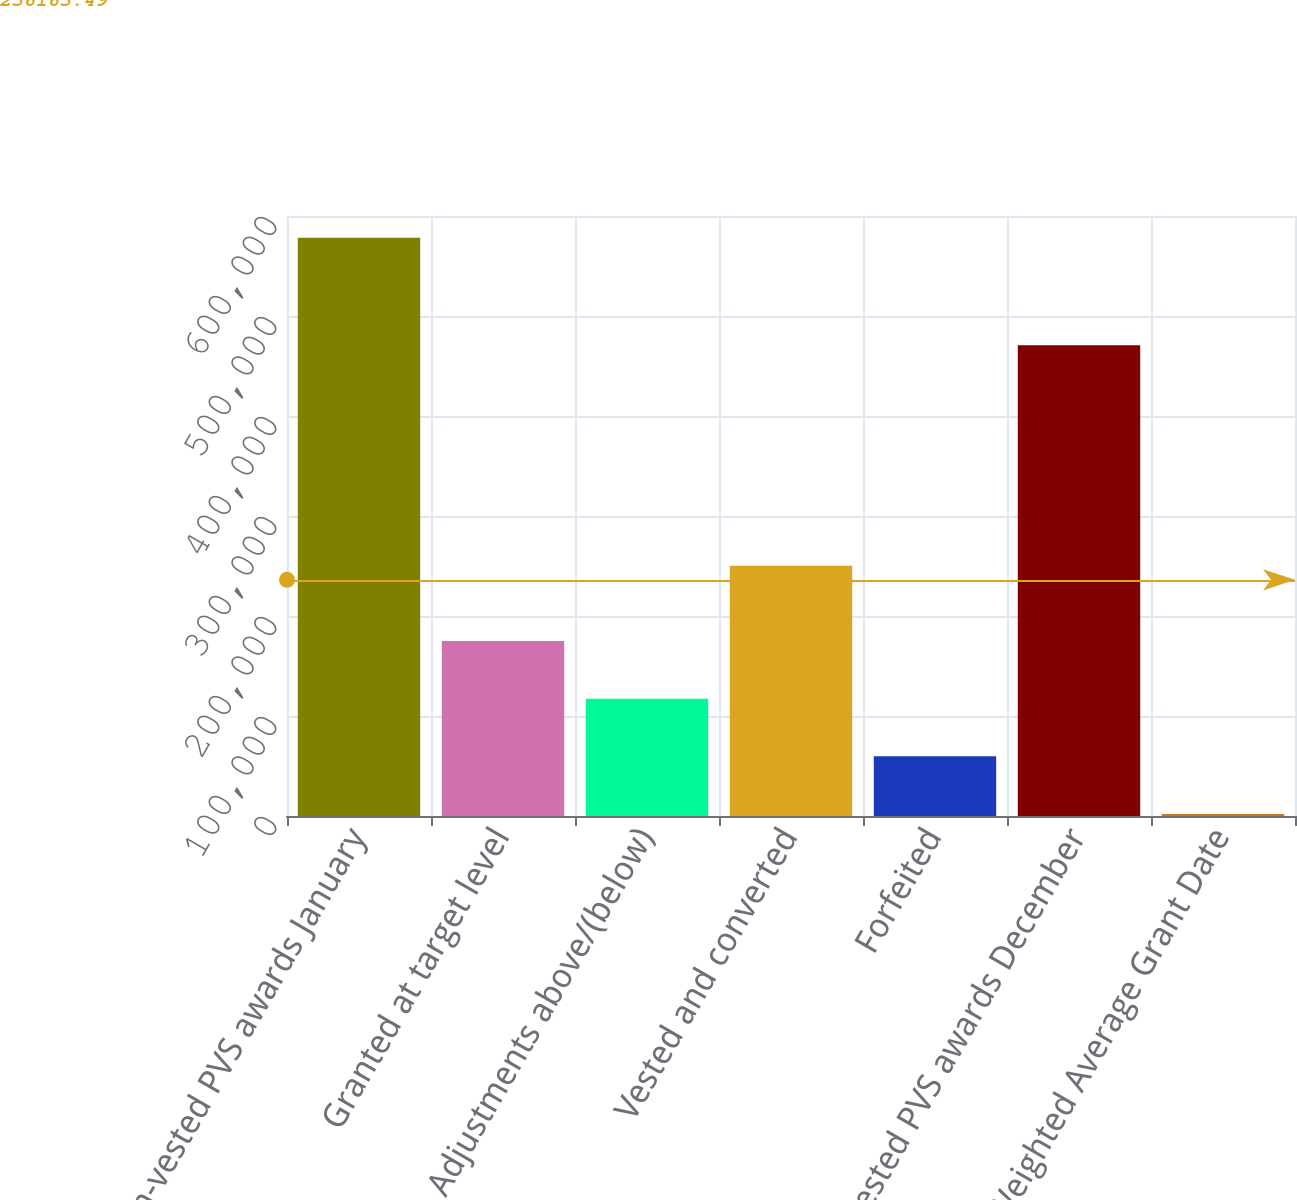Convert chart. <chart><loc_0><loc_0><loc_500><loc_500><bar_chart><fcel>Non-vested PVS awards January<fcel>Granted at target level<fcel>Adjustments above/(below)<fcel>Vested and converted<fcel>Forfeited<fcel>Non-vested PVS awards December<fcel>Weighted Average Grant Date<nl><fcel>578358<fcel>174917<fcel>117283<fcel>250205<fcel>59648.4<fcel>470719<fcel>2014<nl></chart> 